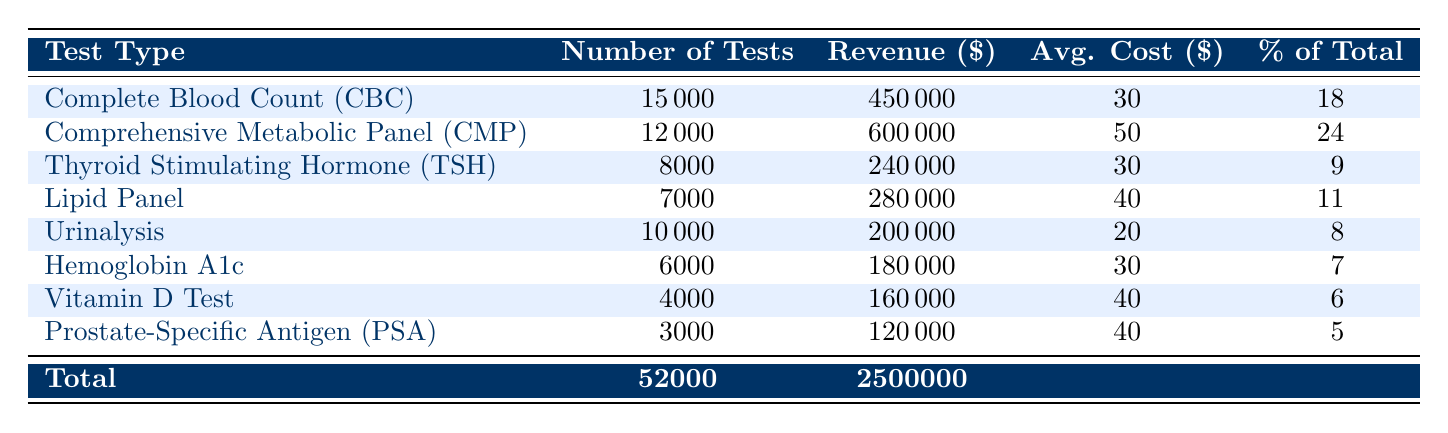What is the total revenue generated from all tests? The total revenue is explicitly provided in the table under the "Total" row. It shows that the total revenue generated from all tests in FY 2022 is $2,500,000.
Answer: $2,500,000 Which test type generated the highest revenue? By examining the "Revenue" column, we can see that the "Comprehensive Metabolic Panel (CMP)" generated $600,000, which is the highest value compared to all other test types listed.
Answer: Comprehensive Metabolic Panel (CMP) What percentage of total revenue was generated by the "Lipid Panel"? The "Lipid Panel" generated $280,000. To find the percentage of total revenue it contributed, we can use the formula: (Revenue from Lipid Panel / Total Revenue) * 100 = (280,000 / 2,500,000) * 100 = 11.2%. The table indicates this is 11%, so it confirms the match.
Answer: 11% How many tests were performed in total? The total number of tests is found in the "Total" row under the "Number of Tests" column. It lists a total of 52,000 tests performed.
Answer: 52,000 Did the "Vitamin D Test" have an average cost per test greater than $30? The average cost per test for "Vitamin D Test" is listed as $40, which is greater than $30.
Answer: Yes What is the average revenue generated per test type for all tests combined? To find the average revenue per test type, we divide the total revenue by the number of different test types. There are 8 test types, so average revenue = $2,500,000 / 8 = $312,500.
Answer: $312,500 Which test type has the lowest number of tests performed? By reviewing the "Number of Tests" column, we find that the "Prostate-Specific Antigen (PSA)" test type had the lowest number of tests performed, with only 3,000 tests.
Answer: Prostate-Specific Antigen (PSA) If we combine the revenue of “Urinalysis” and “Hemoglobin A1c”, what is the total revenue from these tests? The revenue from "Urinalysis" is $200,000 and from "Hemoglobin A1c" is $180,000. Adding these amounts gives us: 200,000 + 180,000 = 380,000.
Answer: $380,000 